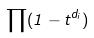<formula> <loc_0><loc_0><loc_500><loc_500>\prod ( 1 - t ^ { d _ { i } } )</formula> 